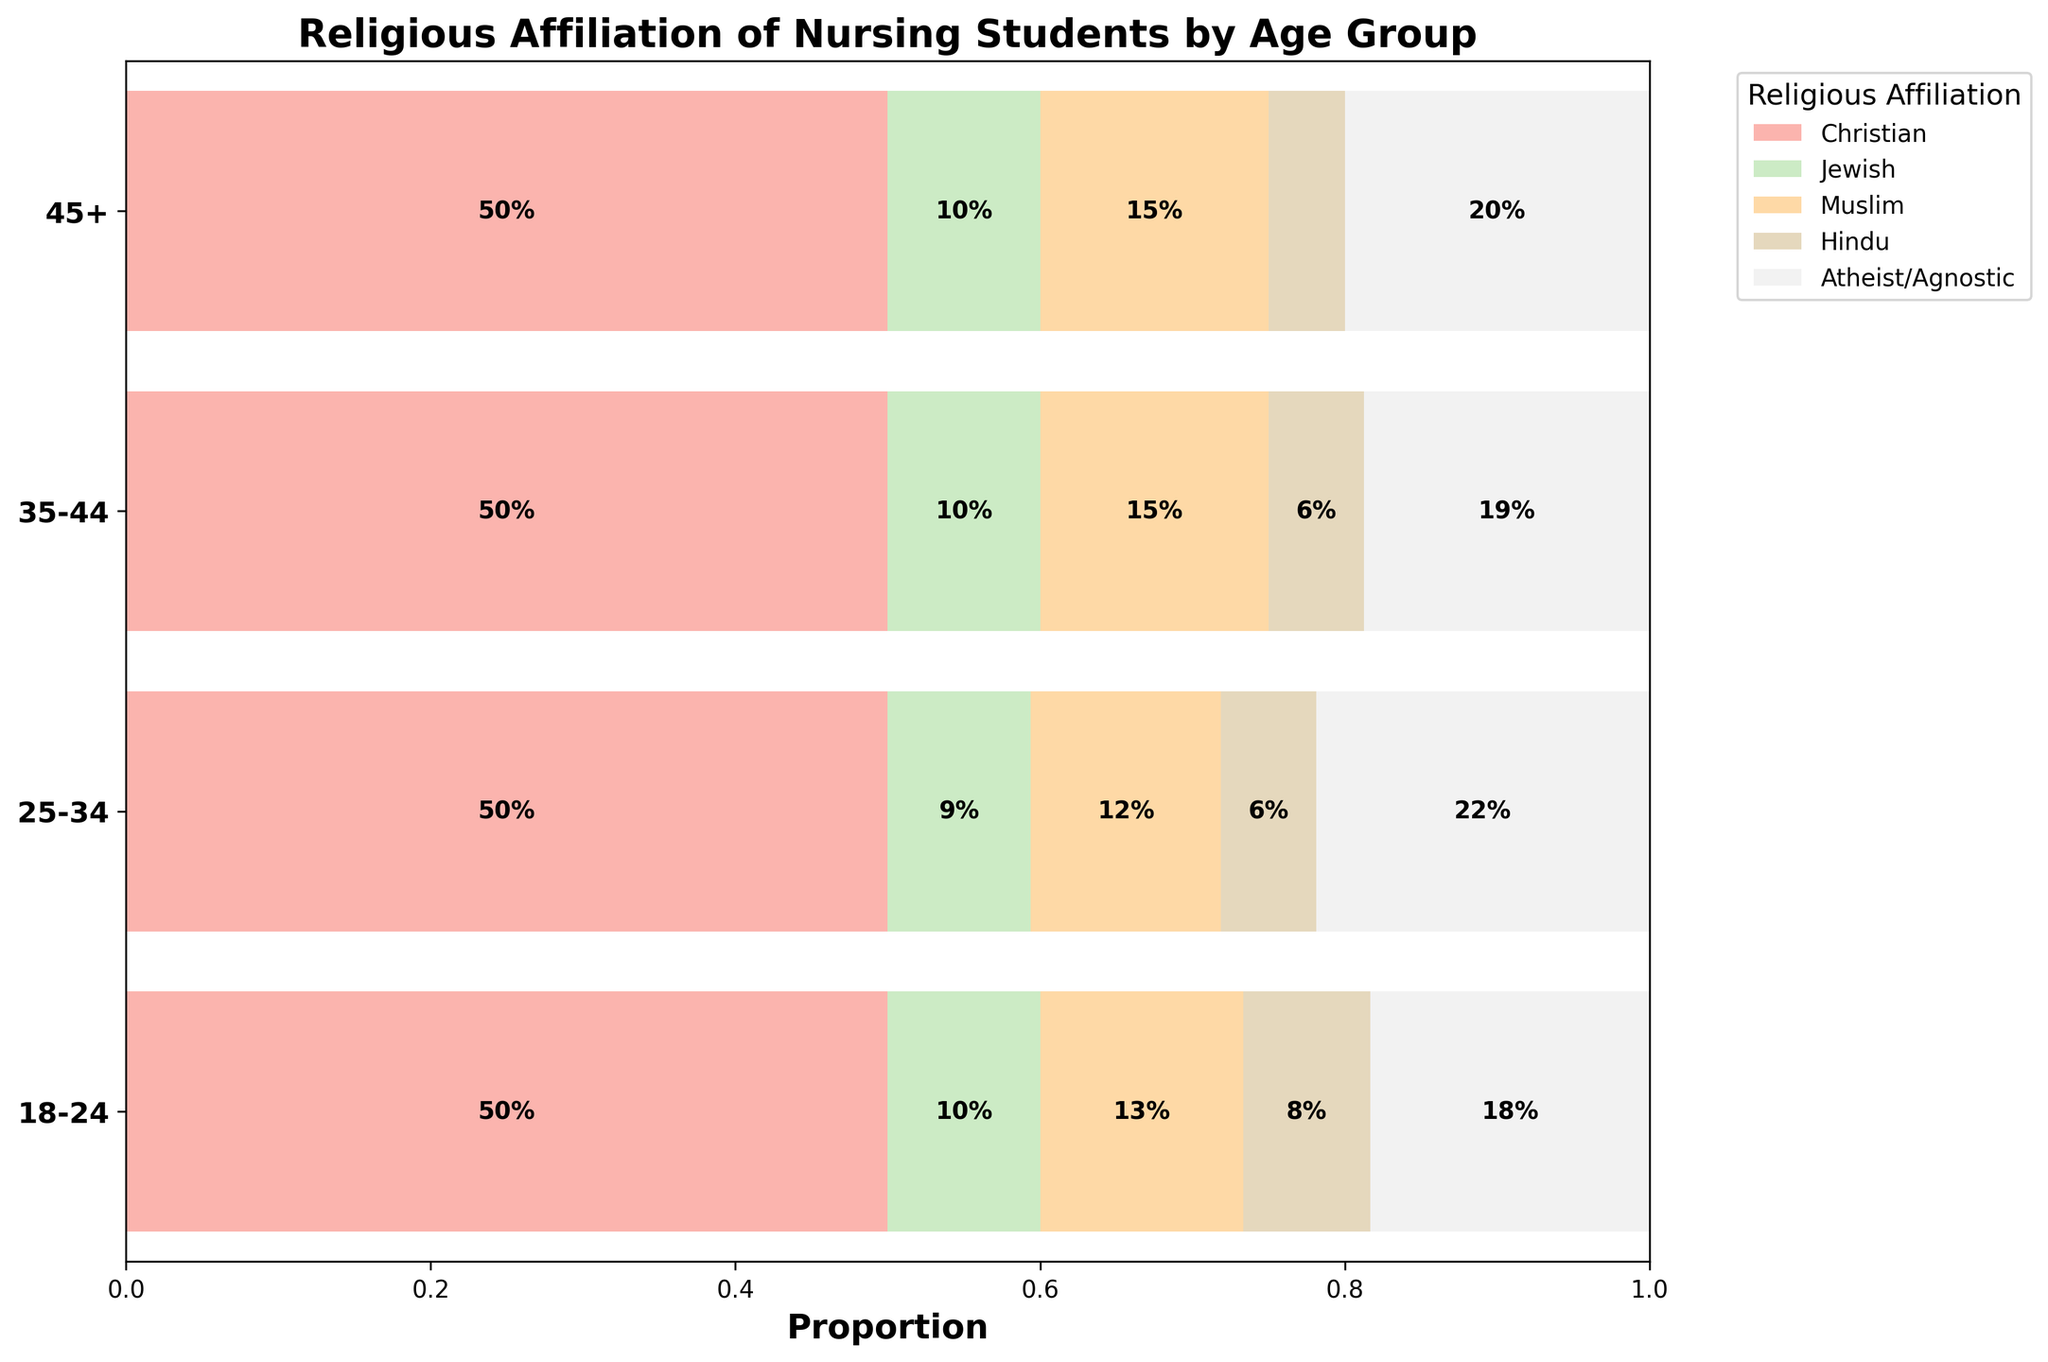What's the title of the figure? The title of the figure is typically written at the top of the plot. In this case, it is clearly labeled in the code.
Answer: 'Religious Affiliation of Nursing Students by Age Group' What are the age groups represented in the figure? By examining the y-axis labels, we can see the different age groups mentioned.
Answer: 18-24, 25-34, 35-44, 45+ Which religious affiliation has the largest proportion among nursing students aged 18-24? To determine this, look at the horizontal bars corresponding to the age group 18-24 and compare their lengths. The longest bar will indicate the largest proportion.
Answer: Christian How does the proportion of Atheist/Agnostic nursing students compare across different age groups? Compare the widths of the segments representing Atheist/Agnostic across all age groups. Notice which segments are wider and which are narrower.
Answer: The proportion of Atheist/Agnostic nursing students is highest in the 18-24 age group and decreases with age Which age group has the smallest proportion of Hindu nursing students? Compare the width of the segments for Hindu students across all age groups. The smallest segment indicates the lowest proportion.
Answer: 45+ What is the sum of proportions of Christian and Jewish nursing students in the 25-34 age group? Look at the segments corresponding to Christian and Jewish in the 25-34 age group and add their widths (proportions) together.
Answer: 0.80 (Christian) + 0.15 (Jewish) = 0.95 In which age group do Muslim nursing students make up the largest proportion? Compare the widths of the bars for Muslim students across all age groups and identify the largest one.
Answer: 18-24 What proportion of nursing students aged 35-44 are neither Christian nor Atheist/Agnostic? Add the proportions of Jewish, Muslim, and Hindu students in the 35-44 age group. Subtract the sum from 1 to find the proportion that is neither Christian nor Atheist/Agnostic.
Answer: 1 - (40/80 + 15/80) = 1 - 55/80 = 0.3125 Which religious affiliation has an almost uniform proportion across all age groups? Compare the segments for each religious affiliation across all age groups. Uniform proportions will have roughly equal segment widths in all age groups.
Answer: Jewish How does the overall proportion of Christian nursing students change with age? Observe the width of the Christian segments from the youngest to the oldest age group and note the changes.
Answer: The proportion decreases with age 